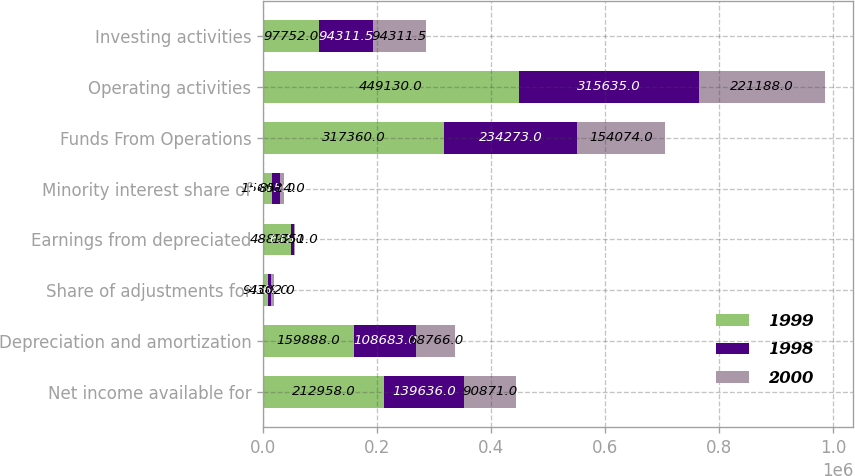<chart> <loc_0><loc_0><loc_500><loc_500><stacked_bar_chart><ecel><fcel>Net income available for<fcel>Depreciation and amortization<fcel>Share of adjustments for<fcel>Earnings from depreciated<fcel>Minority interest share of<fcel>Funds From Operations<fcel>Operating activities<fcel>Investing activities<nl><fcel>1999<fcel>212958<fcel>159888<fcel>9104<fcel>48892<fcel>15698<fcel>317360<fcel>449130<fcel>97752<nl><fcel>1998<fcel>139636<fcel>108683<fcel>5268<fcel>6155<fcel>13159<fcel>234273<fcel>315635<fcel>94311.5<nl><fcel>2000<fcel>90871<fcel>68766<fcel>4302<fcel>1351<fcel>8514<fcel>154074<fcel>221188<fcel>94311.5<nl></chart> 